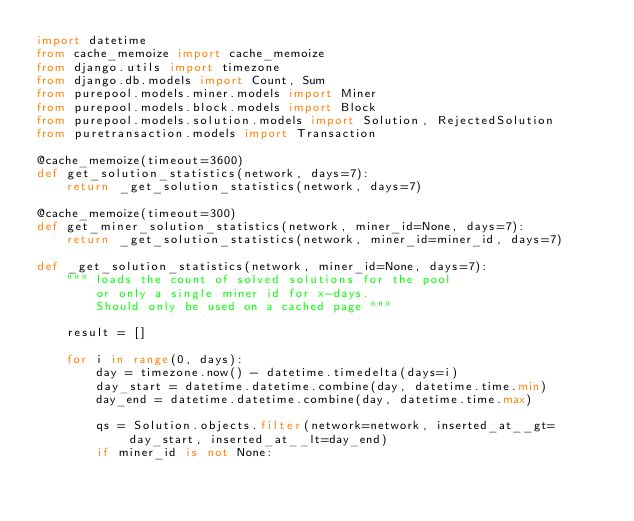Convert code to text. <code><loc_0><loc_0><loc_500><loc_500><_Python_>import datetime
from cache_memoize import cache_memoize
from django.utils import timezone
from django.db.models import Count, Sum
from purepool.models.miner.models import Miner
from purepool.models.block.models import Block
from purepool.models.solution.models import Solution, RejectedSolution
from puretransaction.models import Transaction

@cache_memoize(timeout=3600)
def get_solution_statistics(network, days=7):
    return _get_solution_statistics(network, days=7)

@cache_memoize(timeout=300)
def get_miner_solution_statistics(network, miner_id=None, days=7):
    return _get_solution_statistics(network, miner_id=miner_id, days=7)

def _get_solution_statistics(network, miner_id=None, days=7):
    """ loads the count of solved solutions for the pool
        or only a single miner id for x-days.
        Should only be used on a cached page """

    result = []

    for i in range(0, days):
        day = timezone.now() - datetime.timedelta(days=i)
        day_start = datetime.datetime.combine(day, datetime.time.min)
        day_end = datetime.datetime.combine(day, datetime.time.max)

        qs = Solution.objects.filter(network=network, inserted_at__gt=day_start, inserted_at__lt=day_end)
        if miner_id is not None:</code> 